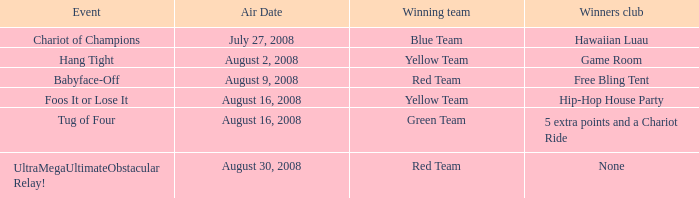How many weeks have a triumphant yellow team, and a happening of foos it or lose it? 4.0. Could you parse the entire table? {'header': ['Event', 'Air Date', 'Winning team', 'Winners club'], 'rows': [['Chariot of Champions', 'July 27, 2008', 'Blue Team', 'Hawaiian Luau'], ['Hang Tight', 'August 2, 2008', 'Yellow Team', 'Game Room'], ['Babyface-Off', 'August 9, 2008', 'Red Team', 'Free Bling Tent'], ['Foos It or Lose It', 'August 16, 2008', 'Yellow Team', 'Hip-Hop House Party'], ['Tug of Four', 'August 16, 2008', 'Green Team', '5 extra points and a Chariot Ride'], ['UltraMegaUltimateObstacular Relay!', 'August 30, 2008', 'Red Team', 'None']]} 